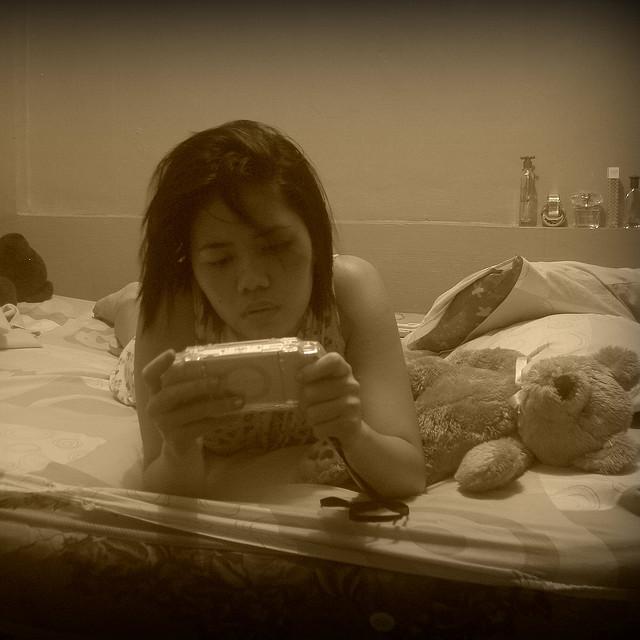Is she in the bathroom?
Keep it brief. No. Is she laying in a bed?
Short answer required. Yes. What's she holding?
Give a very brief answer. Game. 